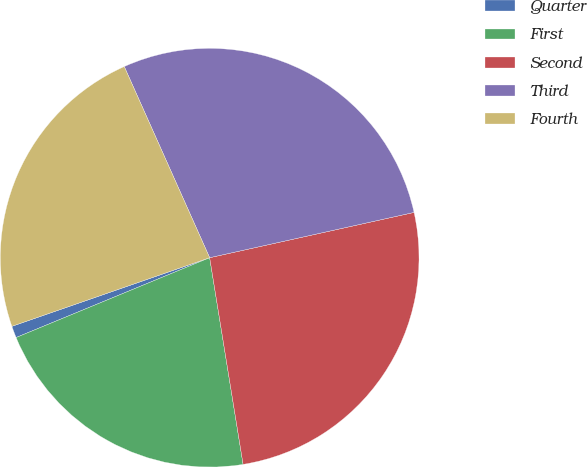Convert chart to OTSL. <chart><loc_0><loc_0><loc_500><loc_500><pie_chart><fcel>Quarter<fcel>First<fcel>Second<fcel>Third<fcel>Fourth<nl><fcel>0.91%<fcel>21.33%<fcel>25.92%<fcel>28.22%<fcel>23.63%<nl></chart> 